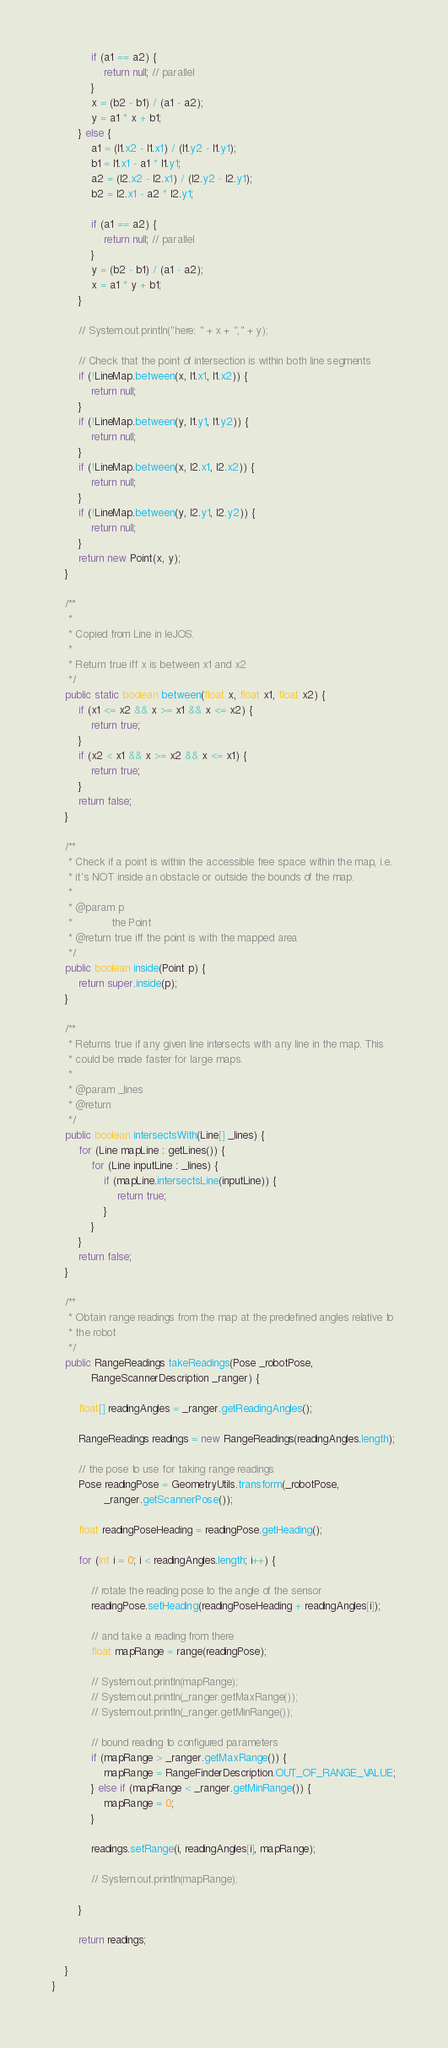Convert code to text. <code><loc_0><loc_0><loc_500><loc_500><_Java_>
			if (a1 == a2) {
				return null; // parallel
			}
			x = (b2 - b1) / (a1 - a2);
			y = a1 * x + b1;
		} else {
			a1 = (l1.x2 - l1.x1) / (l1.y2 - l1.y1);
			b1 = l1.x1 - a1 * l1.y1;
			a2 = (l2.x2 - l2.x1) / (l2.y2 - l2.y1);
			b2 = l2.x1 - a2 * l2.y1;

			if (a1 == a2) {
				return null; // parallel
			}
			y = (b2 - b1) / (a1 - a2);
			x = a1 * y + b1;
		}

		// System.out.println("here: " + x + "," + y);

		// Check that the point of intersection is within both line segments
		if (!LineMap.between(x, l1.x1, l1.x2)) {
			return null;
		}
		if (!LineMap.between(y, l1.y1, l1.y2)) {
			return null;
		}
		if (!LineMap.between(x, l2.x1, l2.x2)) {
			return null;
		}
		if (!LineMap.between(y, l2.y1, l2.y2)) {
			return null;
		}
		return new Point(x, y);
	}

	/**
	 * 
	 * Copied from Line in leJOS.
	 * 
	 * Return true iff x is between x1 and x2
	 */
	public static boolean between(float x, float x1, float x2) {
		if (x1 <= x2 && x >= x1 && x <= x2) {
			return true;
		}
		if (x2 < x1 && x >= x2 && x <= x1) {
			return true;
		}
		return false;
	}

	/**
	 * Check if a point is within the accessible free space within the map, i.e.
	 * it's NOT inside an obstacle or outside the bounds of the map.
	 * 
	 * @param p
	 *            the Point
	 * @return true iff the point is with the mapped area
	 */
	public boolean inside(Point p) {
		return super.inside(p);
	}

	/**
	 * Returns true if any given line intersects with any line in the map. This
	 * could be made faster for large maps.
	 * 
	 * @param _lines
	 * @return
	 */
	public boolean intersectsWith(Line[] _lines) {
		for (Line mapLine : getLines()) {
			for (Line inputLine : _lines) {
				if (mapLine.intersectsLine(inputLine)) {
					return true;
				}
			}
		}
		return false;
	}

	/**
	 * Obtain range readings from the map at the predefined angles relative to
	 * the robot
	 */
	public RangeReadings takeReadings(Pose _robotPose,
			RangeScannerDescription _ranger) {

		float[] readingAngles = _ranger.getReadingAngles();

		RangeReadings readings = new RangeReadings(readingAngles.length);

		// the pose to use for taking range readings
		Pose readingPose = GeometryUtils.transform(_robotPose,
				_ranger.getScannerPose());

		float readingPoseHeading = readingPose.getHeading();

		for (int i = 0; i < readingAngles.length; i++) {

			// rotate the reading pose to the angle of the sensor
			readingPose.setHeading(readingPoseHeading + readingAngles[i]);

			// and take a reading from there
			float mapRange = range(readingPose);

			// System.out.println(mapRange);
			// System.out.println(_ranger.getMaxRange());
			// System.out.println(_ranger.getMinRange());

			// bound reading to configured parameters
			if (mapRange > _ranger.getMaxRange()) {
				mapRange = RangeFinderDescription.OUT_OF_RANGE_VALUE;
			} else if (mapRange < _ranger.getMinRange()) {
				mapRange = 0;
			}

			readings.setRange(i, readingAngles[i], mapRange);

			// System.out.println(mapRange);

		}

		return readings;

	}
}
</code> 